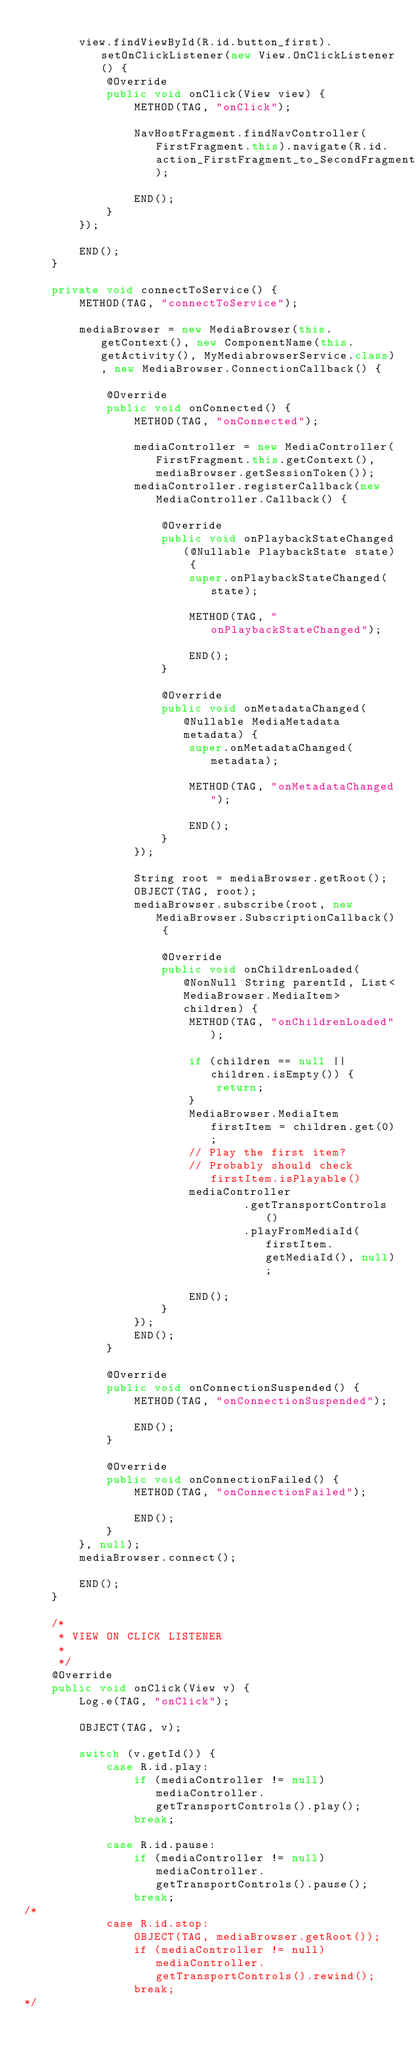<code> <loc_0><loc_0><loc_500><loc_500><_Java_>
        view.findViewById(R.id.button_first).setOnClickListener(new View.OnClickListener() {
            @Override
            public void onClick(View view) {
                METHOD(TAG, "onClick");

                NavHostFragment.findNavController(FirstFragment.this).navigate(R.id.action_FirstFragment_to_SecondFragment);

                END();
            }
        });

        END();
    }

    private void connectToService() {
        METHOD(TAG, "connectToService");

        mediaBrowser = new MediaBrowser(this.getContext(), new ComponentName(this.getActivity(), MyMediabrowserService.class), new MediaBrowser.ConnectionCallback() {

            @Override
            public void onConnected() {
                METHOD(TAG, "onConnected");

                mediaController = new MediaController(FirstFragment.this.getContext(), mediaBrowser.getSessionToken());
                mediaController.registerCallback(new MediaController.Callback() {

                    @Override
                    public void onPlaybackStateChanged(@Nullable PlaybackState state) {
                        super.onPlaybackStateChanged(state);

                        METHOD(TAG, "onPlaybackStateChanged");

                        END();
                    }

                    @Override
                    public void onMetadataChanged(@Nullable MediaMetadata metadata) {
                        super.onMetadataChanged(metadata);

                        METHOD(TAG, "onMetadataChanged");

                        END();
                    }
                });

                String root = mediaBrowser.getRoot();
                OBJECT(TAG, root);
                mediaBrowser.subscribe(root, new MediaBrowser.SubscriptionCallback() {

                    @Override
                    public void onChildrenLoaded(@NonNull String parentId, List<MediaBrowser.MediaItem> children) {
                        METHOD(TAG, "onChildrenLoaded");

                        if (children == null || children.isEmpty()) {
                            return;
                        }
                        MediaBrowser.MediaItem firstItem = children.get(0);
                        // Play the first item?
                        // Probably should check firstItem.isPlayable()
                        mediaController
                                .getTransportControls()
                                .playFromMediaId(firstItem.getMediaId(), null);

                        END();
                    }
                });
                END();
            }

            @Override
            public void onConnectionSuspended() {
                METHOD(TAG, "onConnectionSuspended");

                END();
            }

            @Override
            public void onConnectionFailed() {
                METHOD(TAG, "onConnectionFailed");

                END();
            }
        }, null);
        mediaBrowser.connect();

        END();
    }

    /*
     * VIEW ON CLICK LISTENER
     *
     */
    @Override
    public void onClick(View v) {
        Log.e(TAG, "onClick");

        OBJECT(TAG, v);

        switch (v.getId()) {
            case R.id.play:
                if (mediaController != null) mediaController.getTransportControls().play();
                break;

            case R.id.pause:
                if (mediaController != null) mediaController.getTransportControls().pause();
                break;
/*
            case R.id.stop:
                OBJECT(TAG, mediaBrowser.getRoot());
                if (mediaController != null) mediaController.getTransportControls().rewind();
                break;
*/</code> 